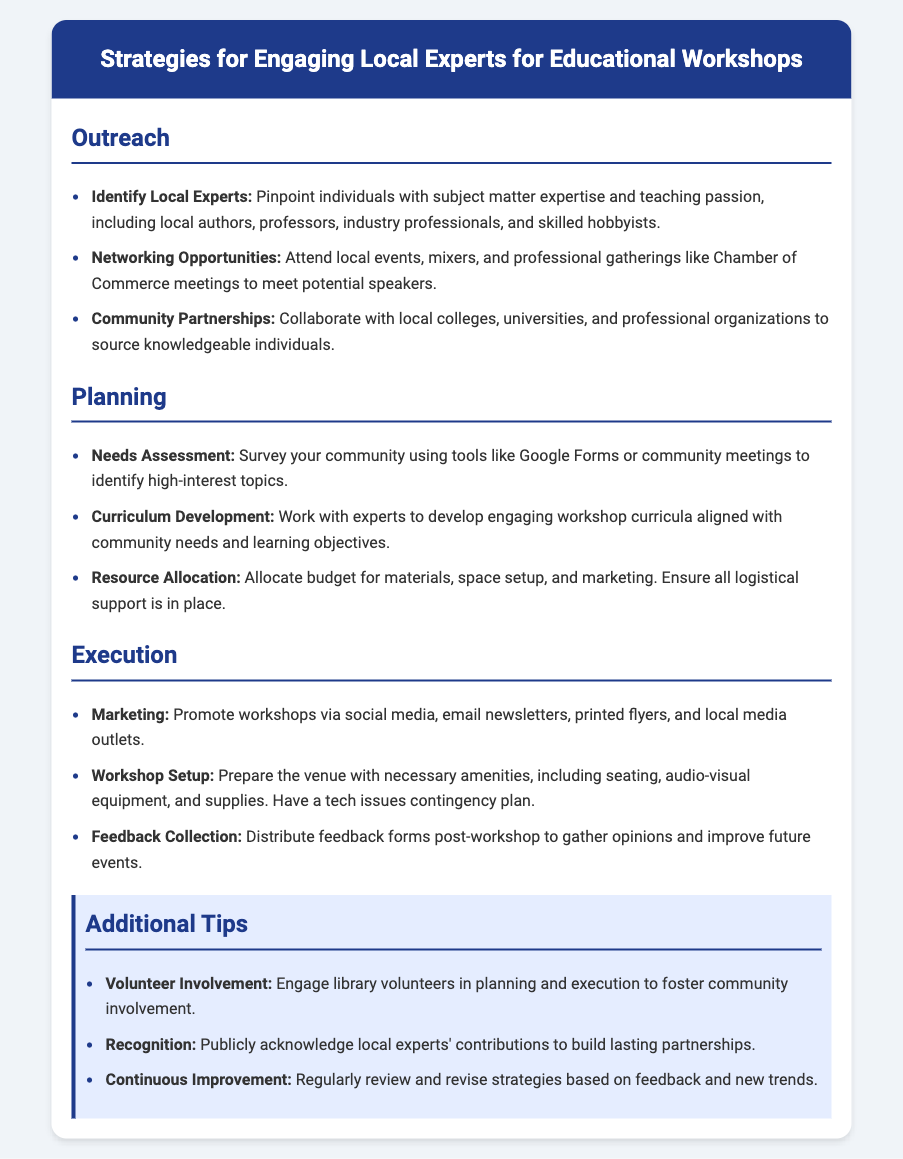what are the three main sections of the document? The document is organized into three main sections: Outreach, Planning, and Execution.
Answer: Outreach, Planning, Execution who should you collaborate with for community partnerships? The document suggests collaborating with local colleges, universities, and professional organizations.
Answer: colleges, universities, professional organizations what tool can be used for needs assessment? A tool mentioned in the document for needs assessment is Google Forms.
Answer: Google Forms what should be promoted via social media? The document states that workshops should be promoted via social media.
Answer: workshops what is one tip for volunteer involvement? One tip mentioned is to engage library volunteers in planning and execution.
Answer: engage library volunteers how should feedback be collected post-workshop? According to the document, feedback should be collected using feedback forms.
Answer: feedback forms what is the purpose of recognizing local experts? The document states that recognition is to build lasting partnerships.
Answer: build lasting partnerships how can logistical support be ensured? Logistical support can be ensured by allocating budget for materials, space setup, and marketing.
Answer: allocating budget what type of events should you attend for networking opportunities? The document mentions attending local events, mixers, and professional gatherings.
Answer: local events, mixers, professional gatherings 